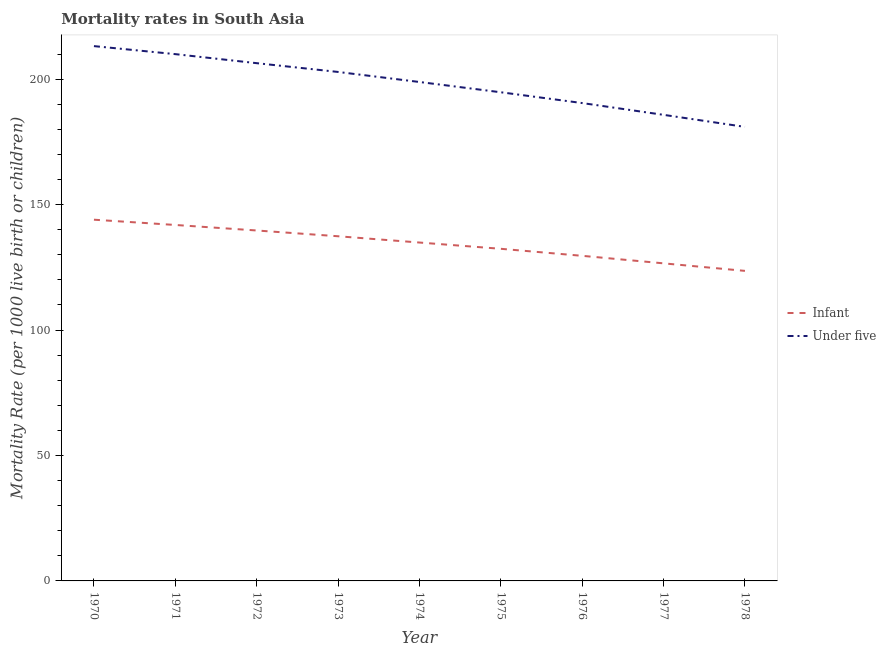What is the infant mortality rate in 1978?
Provide a succinct answer. 123.6. Across all years, what is the maximum under-5 mortality rate?
Your response must be concise. 213.2. Across all years, what is the minimum infant mortality rate?
Your response must be concise. 123.6. In which year was the infant mortality rate maximum?
Your answer should be compact. 1970. In which year was the infant mortality rate minimum?
Offer a terse response. 1978. What is the total infant mortality rate in the graph?
Make the answer very short. 1210.1. What is the difference between the infant mortality rate in 1973 and that in 1977?
Offer a terse response. 10.8. What is the difference between the infant mortality rate in 1972 and the under-5 mortality rate in 1978?
Give a very brief answer. -41.3. What is the average under-5 mortality rate per year?
Keep it short and to the point. 198.17. In the year 1975, what is the difference between the infant mortality rate and under-5 mortality rate?
Give a very brief answer. -62.4. In how many years, is the under-5 mortality rate greater than 40?
Ensure brevity in your answer.  9. What is the ratio of the under-5 mortality rate in 1972 to that in 1978?
Your answer should be very brief. 1.14. What is the difference between the highest and the second highest under-5 mortality rate?
Keep it short and to the point. 3.2. What is the difference between the highest and the lowest under-5 mortality rate?
Keep it short and to the point. 32.2. In how many years, is the infant mortality rate greater than the average infant mortality rate taken over all years?
Give a very brief answer. 5. Does the infant mortality rate monotonically increase over the years?
Your response must be concise. No. Is the infant mortality rate strictly greater than the under-5 mortality rate over the years?
Ensure brevity in your answer.  No. Is the infant mortality rate strictly less than the under-5 mortality rate over the years?
Your answer should be very brief. Yes. How many lines are there?
Give a very brief answer. 2. How many years are there in the graph?
Ensure brevity in your answer.  9. Are the values on the major ticks of Y-axis written in scientific E-notation?
Ensure brevity in your answer.  No. Does the graph contain any zero values?
Provide a short and direct response. No. How are the legend labels stacked?
Your response must be concise. Vertical. What is the title of the graph?
Your answer should be compact. Mortality rates in South Asia. What is the label or title of the X-axis?
Your response must be concise. Year. What is the label or title of the Y-axis?
Make the answer very short. Mortality Rate (per 1000 live birth or children). What is the Mortality Rate (per 1000 live birth or children) in Infant in 1970?
Make the answer very short. 144. What is the Mortality Rate (per 1000 live birth or children) of Under five in 1970?
Your answer should be compact. 213.2. What is the Mortality Rate (per 1000 live birth or children) of Infant in 1971?
Your response must be concise. 141.9. What is the Mortality Rate (per 1000 live birth or children) of Under five in 1971?
Keep it short and to the point. 210. What is the Mortality Rate (per 1000 live birth or children) of Infant in 1972?
Offer a terse response. 139.7. What is the Mortality Rate (per 1000 live birth or children) in Under five in 1972?
Provide a short and direct response. 206.4. What is the Mortality Rate (per 1000 live birth or children) in Infant in 1973?
Offer a very short reply. 137.4. What is the Mortality Rate (per 1000 live birth or children) in Under five in 1973?
Your answer should be compact. 202.9. What is the Mortality Rate (per 1000 live birth or children) in Infant in 1974?
Provide a succinct answer. 134.9. What is the Mortality Rate (per 1000 live birth or children) in Under five in 1974?
Offer a terse response. 198.9. What is the Mortality Rate (per 1000 live birth or children) of Infant in 1975?
Offer a terse response. 132.4. What is the Mortality Rate (per 1000 live birth or children) of Under five in 1975?
Your response must be concise. 194.8. What is the Mortality Rate (per 1000 live birth or children) of Infant in 1976?
Ensure brevity in your answer.  129.6. What is the Mortality Rate (per 1000 live birth or children) in Under five in 1976?
Give a very brief answer. 190.5. What is the Mortality Rate (per 1000 live birth or children) in Infant in 1977?
Ensure brevity in your answer.  126.6. What is the Mortality Rate (per 1000 live birth or children) of Under five in 1977?
Your answer should be very brief. 185.8. What is the Mortality Rate (per 1000 live birth or children) in Infant in 1978?
Provide a short and direct response. 123.6. What is the Mortality Rate (per 1000 live birth or children) of Under five in 1978?
Offer a very short reply. 181. Across all years, what is the maximum Mortality Rate (per 1000 live birth or children) of Infant?
Provide a short and direct response. 144. Across all years, what is the maximum Mortality Rate (per 1000 live birth or children) of Under five?
Provide a succinct answer. 213.2. Across all years, what is the minimum Mortality Rate (per 1000 live birth or children) of Infant?
Your answer should be very brief. 123.6. Across all years, what is the minimum Mortality Rate (per 1000 live birth or children) in Under five?
Give a very brief answer. 181. What is the total Mortality Rate (per 1000 live birth or children) in Infant in the graph?
Provide a short and direct response. 1210.1. What is the total Mortality Rate (per 1000 live birth or children) in Under five in the graph?
Offer a very short reply. 1783.5. What is the difference between the Mortality Rate (per 1000 live birth or children) of Infant in 1970 and that in 1971?
Keep it short and to the point. 2.1. What is the difference between the Mortality Rate (per 1000 live birth or children) in Under five in 1970 and that in 1971?
Your answer should be very brief. 3.2. What is the difference between the Mortality Rate (per 1000 live birth or children) of Infant in 1970 and that in 1972?
Ensure brevity in your answer.  4.3. What is the difference between the Mortality Rate (per 1000 live birth or children) of Under five in 1970 and that in 1972?
Provide a short and direct response. 6.8. What is the difference between the Mortality Rate (per 1000 live birth or children) of Under five in 1970 and that in 1973?
Your answer should be compact. 10.3. What is the difference between the Mortality Rate (per 1000 live birth or children) of Infant in 1970 and that in 1975?
Your answer should be compact. 11.6. What is the difference between the Mortality Rate (per 1000 live birth or children) of Under five in 1970 and that in 1976?
Give a very brief answer. 22.7. What is the difference between the Mortality Rate (per 1000 live birth or children) in Infant in 1970 and that in 1977?
Offer a terse response. 17.4. What is the difference between the Mortality Rate (per 1000 live birth or children) in Under five in 1970 and that in 1977?
Make the answer very short. 27.4. What is the difference between the Mortality Rate (per 1000 live birth or children) in Infant in 1970 and that in 1978?
Ensure brevity in your answer.  20.4. What is the difference between the Mortality Rate (per 1000 live birth or children) in Under five in 1970 and that in 1978?
Your answer should be compact. 32.2. What is the difference between the Mortality Rate (per 1000 live birth or children) in Infant in 1971 and that in 1973?
Your answer should be very brief. 4.5. What is the difference between the Mortality Rate (per 1000 live birth or children) in Under five in 1971 and that in 1974?
Ensure brevity in your answer.  11.1. What is the difference between the Mortality Rate (per 1000 live birth or children) of Infant in 1971 and that in 1975?
Ensure brevity in your answer.  9.5. What is the difference between the Mortality Rate (per 1000 live birth or children) in Under five in 1971 and that in 1975?
Provide a short and direct response. 15.2. What is the difference between the Mortality Rate (per 1000 live birth or children) in Under five in 1971 and that in 1976?
Your response must be concise. 19.5. What is the difference between the Mortality Rate (per 1000 live birth or children) in Infant in 1971 and that in 1977?
Make the answer very short. 15.3. What is the difference between the Mortality Rate (per 1000 live birth or children) of Under five in 1971 and that in 1977?
Your response must be concise. 24.2. What is the difference between the Mortality Rate (per 1000 live birth or children) in Under five in 1971 and that in 1978?
Your response must be concise. 29. What is the difference between the Mortality Rate (per 1000 live birth or children) of Infant in 1972 and that in 1973?
Keep it short and to the point. 2.3. What is the difference between the Mortality Rate (per 1000 live birth or children) in Under five in 1972 and that in 1973?
Provide a short and direct response. 3.5. What is the difference between the Mortality Rate (per 1000 live birth or children) in Infant in 1972 and that in 1975?
Your answer should be very brief. 7.3. What is the difference between the Mortality Rate (per 1000 live birth or children) of Under five in 1972 and that in 1975?
Give a very brief answer. 11.6. What is the difference between the Mortality Rate (per 1000 live birth or children) in Under five in 1972 and that in 1976?
Keep it short and to the point. 15.9. What is the difference between the Mortality Rate (per 1000 live birth or children) of Under five in 1972 and that in 1977?
Offer a very short reply. 20.6. What is the difference between the Mortality Rate (per 1000 live birth or children) in Infant in 1972 and that in 1978?
Provide a short and direct response. 16.1. What is the difference between the Mortality Rate (per 1000 live birth or children) of Under five in 1972 and that in 1978?
Offer a very short reply. 25.4. What is the difference between the Mortality Rate (per 1000 live birth or children) of Under five in 1973 and that in 1974?
Offer a very short reply. 4. What is the difference between the Mortality Rate (per 1000 live birth or children) in Infant in 1973 and that in 1976?
Your answer should be compact. 7.8. What is the difference between the Mortality Rate (per 1000 live birth or children) of Infant in 1973 and that in 1977?
Ensure brevity in your answer.  10.8. What is the difference between the Mortality Rate (per 1000 live birth or children) in Under five in 1973 and that in 1977?
Offer a terse response. 17.1. What is the difference between the Mortality Rate (per 1000 live birth or children) in Infant in 1973 and that in 1978?
Keep it short and to the point. 13.8. What is the difference between the Mortality Rate (per 1000 live birth or children) in Under five in 1973 and that in 1978?
Offer a terse response. 21.9. What is the difference between the Mortality Rate (per 1000 live birth or children) in Under five in 1974 and that in 1976?
Provide a short and direct response. 8.4. What is the difference between the Mortality Rate (per 1000 live birth or children) of Infant in 1974 and that in 1977?
Your answer should be very brief. 8.3. What is the difference between the Mortality Rate (per 1000 live birth or children) of Infant in 1974 and that in 1978?
Provide a short and direct response. 11.3. What is the difference between the Mortality Rate (per 1000 live birth or children) in Infant in 1975 and that in 1976?
Provide a succinct answer. 2.8. What is the difference between the Mortality Rate (per 1000 live birth or children) of Infant in 1976 and that in 1977?
Your response must be concise. 3. What is the difference between the Mortality Rate (per 1000 live birth or children) in Infant in 1976 and that in 1978?
Offer a very short reply. 6. What is the difference between the Mortality Rate (per 1000 live birth or children) of Under five in 1977 and that in 1978?
Your answer should be compact. 4.8. What is the difference between the Mortality Rate (per 1000 live birth or children) of Infant in 1970 and the Mortality Rate (per 1000 live birth or children) of Under five in 1971?
Provide a succinct answer. -66. What is the difference between the Mortality Rate (per 1000 live birth or children) in Infant in 1970 and the Mortality Rate (per 1000 live birth or children) in Under five in 1972?
Keep it short and to the point. -62.4. What is the difference between the Mortality Rate (per 1000 live birth or children) in Infant in 1970 and the Mortality Rate (per 1000 live birth or children) in Under five in 1973?
Ensure brevity in your answer.  -58.9. What is the difference between the Mortality Rate (per 1000 live birth or children) in Infant in 1970 and the Mortality Rate (per 1000 live birth or children) in Under five in 1974?
Offer a terse response. -54.9. What is the difference between the Mortality Rate (per 1000 live birth or children) in Infant in 1970 and the Mortality Rate (per 1000 live birth or children) in Under five in 1975?
Ensure brevity in your answer.  -50.8. What is the difference between the Mortality Rate (per 1000 live birth or children) in Infant in 1970 and the Mortality Rate (per 1000 live birth or children) in Under five in 1976?
Keep it short and to the point. -46.5. What is the difference between the Mortality Rate (per 1000 live birth or children) in Infant in 1970 and the Mortality Rate (per 1000 live birth or children) in Under five in 1977?
Ensure brevity in your answer.  -41.8. What is the difference between the Mortality Rate (per 1000 live birth or children) in Infant in 1970 and the Mortality Rate (per 1000 live birth or children) in Under five in 1978?
Provide a short and direct response. -37. What is the difference between the Mortality Rate (per 1000 live birth or children) in Infant in 1971 and the Mortality Rate (per 1000 live birth or children) in Under five in 1972?
Make the answer very short. -64.5. What is the difference between the Mortality Rate (per 1000 live birth or children) of Infant in 1971 and the Mortality Rate (per 1000 live birth or children) of Under five in 1973?
Offer a terse response. -61. What is the difference between the Mortality Rate (per 1000 live birth or children) in Infant in 1971 and the Mortality Rate (per 1000 live birth or children) in Under five in 1974?
Ensure brevity in your answer.  -57. What is the difference between the Mortality Rate (per 1000 live birth or children) of Infant in 1971 and the Mortality Rate (per 1000 live birth or children) of Under five in 1975?
Your answer should be very brief. -52.9. What is the difference between the Mortality Rate (per 1000 live birth or children) of Infant in 1971 and the Mortality Rate (per 1000 live birth or children) of Under five in 1976?
Make the answer very short. -48.6. What is the difference between the Mortality Rate (per 1000 live birth or children) of Infant in 1971 and the Mortality Rate (per 1000 live birth or children) of Under five in 1977?
Ensure brevity in your answer.  -43.9. What is the difference between the Mortality Rate (per 1000 live birth or children) in Infant in 1971 and the Mortality Rate (per 1000 live birth or children) in Under five in 1978?
Keep it short and to the point. -39.1. What is the difference between the Mortality Rate (per 1000 live birth or children) in Infant in 1972 and the Mortality Rate (per 1000 live birth or children) in Under five in 1973?
Ensure brevity in your answer.  -63.2. What is the difference between the Mortality Rate (per 1000 live birth or children) in Infant in 1972 and the Mortality Rate (per 1000 live birth or children) in Under five in 1974?
Make the answer very short. -59.2. What is the difference between the Mortality Rate (per 1000 live birth or children) in Infant in 1972 and the Mortality Rate (per 1000 live birth or children) in Under five in 1975?
Make the answer very short. -55.1. What is the difference between the Mortality Rate (per 1000 live birth or children) in Infant in 1972 and the Mortality Rate (per 1000 live birth or children) in Under five in 1976?
Keep it short and to the point. -50.8. What is the difference between the Mortality Rate (per 1000 live birth or children) in Infant in 1972 and the Mortality Rate (per 1000 live birth or children) in Under five in 1977?
Provide a succinct answer. -46.1. What is the difference between the Mortality Rate (per 1000 live birth or children) of Infant in 1972 and the Mortality Rate (per 1000 live birth or children) of Under five in 1978?
Keep it short and to the point. -41.3. What is the difference between the Mortality Rate (per 1000 live birth or children) of Infant in 1973 and the Mortality Rate (per 1000 live birth or children) of Under five in 1974?
Provide a succinct answer. -61.5. What is the difference between the Mortality Rate (per 1000 live birth or children) of Infant in 1973 and the Mortality Rate (per 1000 live birth or children) of Under five in 1975?
Keep it short and to the point. -57.4. What is the difference between the Mortality Rate (per 1000 live birth or children) of Infant in 1973 and the Mortality Rate (per 1000 live birth or children) of Under five in 1976?
Offer a terse response. -53.1. What is the difference between the Mortality Rate (per 1000 live birth or children) of Infant in 1973 and the Mortality Rate (per 1000 live birth or children) of Under five in 1977?
Offer a terse response. -48.4. What is the difference between the Mortality Rate (per 1000 live birth or children) in Infant in 1973 and the Mortality Rate (per 1000 live birth or children) in Under five in 1978?
Make the answer very short. -43.6. What is the difference between the Mortality Rate (per 1000 live birth or children) in Infant in 1974 and the Mortality Rate (per 1000 live birth or children) in Under five in 1975?
Make the answer very short. -59.9. What is the difference between the Mortality Rate (per 1000 live birth or children) of Infant in 1974 and the Mortality Rate (per 1000 live birth or children) of Under five in 1976?
Your answer should be very brief. -55.6. What is the difference between the Mortality Rate (per 1000 live birth or children) in Infant in 1974 and the Mortality Rate (per 1000 live birth or children) in Under five in 1977?
Your answer should be very brief. -50.9. What is the difference between the Mortality Rate (per 1000 live birth or children) of Infant in 1974 and the Mortality Rate (per 1000 live birth or children) of Under five in 1978?
Your answer should be compact. -46.1. What is the difference between the Mortality Rate (per 1000 live birth or children) in Infant in 1975 and the Mortality Rate (per 1000 live birth or children) in Under five in 1976?
Your answer should be compact. -58.1. What is the difference between the Mortality Rate (per 1000 live birth or children) in Infant in 1975 and the Mortality Rate (per 1000 live birth or children) in Under five in 1977?
Give a very brief answer. -53.4. What is the difference between the Mortality Rate (per 1000 live birth or children) of Infant in 1975 and the Mortality Rate (per 1000 live birth or children) of Under five in 1978?
Offer a very short reply. -48.6. What is the difference between the Mortality Rate (per 1000 live birth or children) in Infant in 1976 and the Mortality Rate (per 1000 live birth or children) in Under five in 1977?
Offer a very short reply. -56.2. What is the difference between the Mortality Rate (per 1000 live birth or children) of Infant in 1976 and the Mortality Rate (per 1000 live birth or children) of Under five in 1978?
Your answer should be very brief. -51.4. What is the difference between the Mortality Rate (per 1000 live birth or children) in Infant in 1977 and the Mortality Rate (per 1000 live birth or children) in Under five in 1978?
Offer a terse response. -54.4. What is the average Mortality Rate (per 1000 live birth or children) of Infant per year?
Your answer should be very brief. 134.46. What is the average Mortality Rate (per 1000 live birth or children) in Under five per year?
Offer a very short reply. 198.17. In the year 1970, what is the difference between the Mortality Rate (per 1000 live birth or children) of Infant and Mortality Rate (per 1000 live birth or children) of Under five?
Provide a short and direct response. -69.2. In the year 1971, what is the difference between the Mortality Rate (per 1000 live birth or children) in Infant and Mortality Rate (per 1000 live birth or children) in Under five?
Keep it short and to the point. -68.1. In the year 1972, what is the difference between the Mortality Rate (per 1000 live birth or children) in Infant and Mortality Rate (per 1000 live birth or children) in Under five?
Ensure brevity in your answer.  -66.7. In the year 1973, what is the difference between the Mortality Rate (per 1000 live birth or children) of Infant and Mortality Rate (per 1000 live birth or children) of Under five?
Your answer should be very brief. -65.5. In the year 1974, what is the difference between the Mortality Rate (per 1000 live birth or children) of Infant and Mortality Rate (per 1000 live birth or children) of Under five?
Your response must be concise. -64. In the year 1975, what is the difference between the Mortality Rate (per 1000 live birth or children) of Infant and Mortality Rate (per 1000 live birth or children) of Under five?
Keep it short and to the point. -62.4. In the year 1976, what is the difference between the Mortality Rate (per 1000 live birth or children) in Infant and Mortality Rate (per 1000 live birth or children) in Under five?
Offer a terse response. -60.9. In the year 1977, what is the difference between the Mortality Rate (per 1000 live birth or children) in Infant and Mortality Rate (per 1000 live birth or children) in Under five?
Keep it short and to the point. -59.2. In the year 1978, what is the difference between the Mortality Rate (per 1000 live birth or children) of Infant and Mortality Rate (per 1000 live birth or children) of Under five?
Offer a terse response. -57.4. What is the ratio of the Mortality Rate (per 1000 live birth or children) of Infant in 1970 to that in 1971?
Provide a short and direct response. 1.01. What is the ratio of the Mortality Rate (per 1000 live birth or children) in Under five in 1970 to that in 1971?
Make the answer very short. 1.02. What is the ratio of the Mortality Rate (per 1000 live birth or children) in Infant in 1970 to that in 1972?
Make the answer very short. 1.03. What is the ratio of the Mortality Rate (per 1000 live birth or children) in Under five in 1970 to that in 1972?
Give a very brief answer. 1.03. What is the ratio of the Mortality Rate (per 1000 live birth or children) of Infant in 1970 to that in 1973?
Ensure brevity in your answer.  1.05. What is the ratio of the Mortality Rate (per 1000 live birth or children) of Under five in 1970 to that in 1973?
Ensure brevity in your answer.  1.05. What is the ratio of the Mortality Rate (per 1000 live birth or children) in Infant in 1970 to that in 1974?
Offer a very short reply. 1.07. What is the ratio of the Mortality Rate (per 1000 live birth or children) of Under five in 1970 to that in 1974?
Provide a short and direct response. 1.07. What is the ratio of the Mortality Rate (per 1000 live birth or children) of Infant in 1970 to that in 1975?
Give a very brief answer. 1.09. What is the ratio of the Mortality Rate (per 1000 live birth or children) of Under five in 1970 to that in 1975?
Your answer should be compact. 1.09. What is the ratio of the Mortality Rate (per 1000 live birth or children) in Under five in 1970 to that in 1976?
Keep it short and to the point. 1.12. What is the ratio of the Mortality Rate (per 1000 live birth or children) in Infant in 1970 to that in 1977?
Offer a terse response. 1.14. What is the ratio of the Mortality Rate (per 1000 live birth or children) of Under five in 1970 to that in 1977?
Offer a terse response. 1.15. What is the ratio of the Mortality Rate (per 1000 live birth or children) in Infant in 1970 to that in 1978?
Provide a short and direct response. 1.17. What is the ratio of the Mortality Rate (per 1000 live birth or children) of Under five in 1970 to that in 1978?
Ensure brevity in your answer.  1.18. What is the ratio of the Mortality Rate (per 1000 live birth or children) of Infant in 1971 to that in 1972?
Keep it short and to the point. 1.02. What is the ratio of the Mortality Rate (per 1000 live birth or children) of Under five in 1971 to that in 1972?
Provide a succinct answer. 1.02. What is the ratio of the Mortality Rate (per 1000 live birth or children) in Infant in 1971 to that in 1973?
Your response must be concise. 1.03. What is the ratio of the Mortality Rate (per 1000 live birth or children) of Under five in 1971 to that in 1973?
Give a very brief answer. 1.03. What is the ratio of the Mortality Rate (per 1000 live birth or children) in Infant in 1971 to that in 1974?
Offer a terse response. 1.05. What is the ratio of the Mortality Rate (per 1000 live birth or children) in Under five in 1971 to that in 1974?
Give a very brief answer. 1.06. What is the ratio of the Mortality Rate (per 1000 live birth or children) in Infant in 1971 to that in 1975?
Provide a short and direct response. 1.07. What is the ratio of the Mortality Rate (per 1000 live birth or children) of Under five in 1971 to that in 1975?
Offer a terse response. 1.08. What is the ratio of the Mortality Rate (per 1000 live birth or children) in Infant in 1971 to that in 1976?
Give a very brief answer. 1.09. What is the ratio of the Mortality Rate (per 1000 live birth or children) of Under five in 1971 to that in 1976?
Give a very brief answer. 1.1. What is the ratio of the Mortality Rate (per 1000 live birth or children) in Infant in 1971 to that in 1977?
Your response must be concise. 1.12. What is the ratio of the Mortality Rate (per 1000 live birth or children) of Under five in 1971 to that in 1977?
Provide a short and direct response. 1.13. What is the ratio of the Mortality Rate (per 1000 live birth or children) of Infant in 1971 to that in 1978?
Your response must be concise. 1.15. What is the ratio of the Mortality Rate (per 1000 live birth or children) of Under five in 1971 to that in 1978?
Your response must be concise. 1.16. What is the ratio of the Mortality Rate (per 1000 live birth or children) in Infant in 1972 to that in 1973?
Your answer should be very brief. 1.02. What is the ratio of the Mortality Rate (per 1000 live birth or children) in Under five in 1972 to that in 1973?
Your response must be concise. 1.02. What is the ratio of the Mortality Rate (per 1000 live birth or children) in Infant in 1972 to that in 1974?
Keep it short and to the point. 1.04. What is the ratio of the Mortality Rate (per 1000 live birth or children) in Under five in 1972 to that in 1974?
Your answer should be very brief. 1.04. What is the ratio of the Mortality Rate (per 1000 live birth or children) in Infant in 1972 to that in 1975?
Make the answer very short. 1.06. What is the ratio of the Mortality Rate (per 1000 live birth or children) of Under five in 1972 to that in 1975?
Make the answer very short. 1.06. What is the ratio of the Mortality Rate (per 1000 live birth or children) of Infant in 1972 to that in 1976?
Provide a succinct answer. 1.08. What is the ratio of the Mortality Rate (per 1000 live birth or children) of Under five in 1972 to that in 1976?
Keep it short and to the point. 1.08. What is the ratio of the Mortality Rate (per 1000 live birth or children) in Infant in 1972 to that in 1977?
Provide a short and direct response. 1.1. What is the ratio of the Mortality Rate (per 1000 live birth or children) in Under five in 1972 to that in 1977?
Keep it short and to the point. 1.11. What is the ratio of the Mortality Rate (per 1000 live birth or children) of Infant in 1972 to that in 1978?
Ensure brevity in your answer.  1.13. What is the ratio of the Mortality Rate (per 1000 live birth or children) in Under five in 1972 to that in 1978?
Provide a succinct answer. 1.14. What is the ratio of the Mortality Rate (per 1000 live birth or children) in Infant in 1973 to that in 1974?
Keep it short and to the point. 1.02. What is the ratio of the Mortality Rate (per 1000 live birth or children) of Under five in 1973 to that in 1974?
Your response must be concise. 1.02. What is the ratio of the Mortality Rate (per 1000 live birth or children) of Infant in 1973 to that in 1975?
Your response must be concise. 1.04. What is the ratio of the Mortality Rate (per 1000 live birth or children) in Under five in 1973 to that in 1975?
Keep it short and to the point. 1.04. What is the ratio of the Mortality Rate (per 1000 live birth or children) in Infant in 1973 to that in 1976?
Give a very brief answer. 1.06. What is the ratio of the Mortality Rate (per 1000 live birth or children) of Under five in 1973 to that in 1976?
Make the answer very short. 1.07. What is the ratio of the Mortality Rate (per 1000 live birth or children) in Infant in 1973 to that in 1977?
Your answer should be compact. 1.09. What is the ratio of the Mortality Rate (per 1000 live birth or children) in Under five in 1973 to that in 1977?
Your answer should be compact. 1.09. What is the ratio of the Mortality Rate (per 1000 live birth or children) of Infant in 1973 to that in 1978?
Offer a very short reply. 1.11. What is the ratio of the Mortality Rate (per 1000 live birth or children) in Under five in 1973 to that in 1978?
Your response must be concise. 1.12. What is the ratio of the Mortality Rate (per 1000 live birth or children) in Infant in 1974 to that in 1975?
Your response must be concise. 1.02. What is the ratio of the Mortality Rate (per 1000 live birth or children) in Infant in 1974 to that in 1976?
Offer a terse response. 1.04. What is the ratio of the Mortality Rate (per 1000 live birth or children) in Under five in 1974 to that in 1976?
Give a very brief answer. 1.04. What is the ratio of the Mortality Rate (per 1000 live birth or children) of Infant in 1974 to that in 1977?
Give a very brief answer. 1.07. What is the ratio of the Mortality Rate (per 1000 live birth or children) of Under five in 1974 to that in 1977?
Offer a terse response. 1.07. What is the ratio of the Mortality Rate (per 1000 live birth or children) in Infant in 1974 to that in 1978?
Your response must be concise. 1.09. What is the ratio of the Mortality Rate (per 1000 live birth or children) of Under five in 1974 to that in 1978?
Give a very brief answer. 1.1. What is the ratio of the Mortality Rate (per 1000 live birth or children) of Infant in 1975 to that in 1976?
Ensure brevity in your answer.  1.02. What is the ratio of the Mortality Rate (per 1000 live birth or children) of Under five in 1975 to that in 1976?
Provide a succinct answer. 1.02. What is the ratio of the Mortality Rate (per 1000 live birth or children) of Infant in 1975 to that in 1977?
Give a very brief answer. 1.05. What is the ratio of the Mortality Rate (per 1000 live birth or children) in Under five in 1975 to that in 1977?
Keep it short and to the point. 1.05. What is the ratio of the Mortality Rate (per 1000 live birth or children) in Infant in 1975 to that in 1978?
Make the answer very short. 1.07. What is the ratio of the Mortality Rate (per 1000 live birth or children) of Under five in 1975 to that in 1978?
Offer a very short reply. 1.08. What is the ratio of the Mortality Rate (per 1000 live birth or children) of Infant in 1976 to that in 1977?
Your answer should be very brief. 1.02. What is the ratio of the Mortality Rate (per 1000 live birth or children) of Under five in 1976 to that in 1977?
Give a very brief answer. 1.03. What is the ratio of the Mortality Rate (per 1000 live birth or children) of Infant in 1976 to that in 1978?
Provide a short and direct response. 1.05. What is the ratio of the Mortality Rate (per 1000 live birth or children) of Under five in 1976 to that in 1978?
Your answer should be very brief. 1.05. What is the ratio of the Mortality Rate (per 1000 live birth or children) in Infant in 1977 to that in 1978?
Your answer should be very brief. 1.02. What is the ratio of the Mortality Rate (per 1000 live birth or children) in Under five in 1977 to that in 1978?
Make the answer very short. 1.03. What is the difference between the highest and the second highest Mortality Rate (per 1000 live birth or children) of Under five?
Your answer should be very brief. 3.2. What is the difference between the highest and the lowest Mortality Rate (per 1000 live birth or children) of Infant?
Your response must be concise. 20.4. What is the difference between the highest and the lowest Mortality Rate (per 1000 live birth or children) in Under five?
Offer a very short reply. 32.2. 